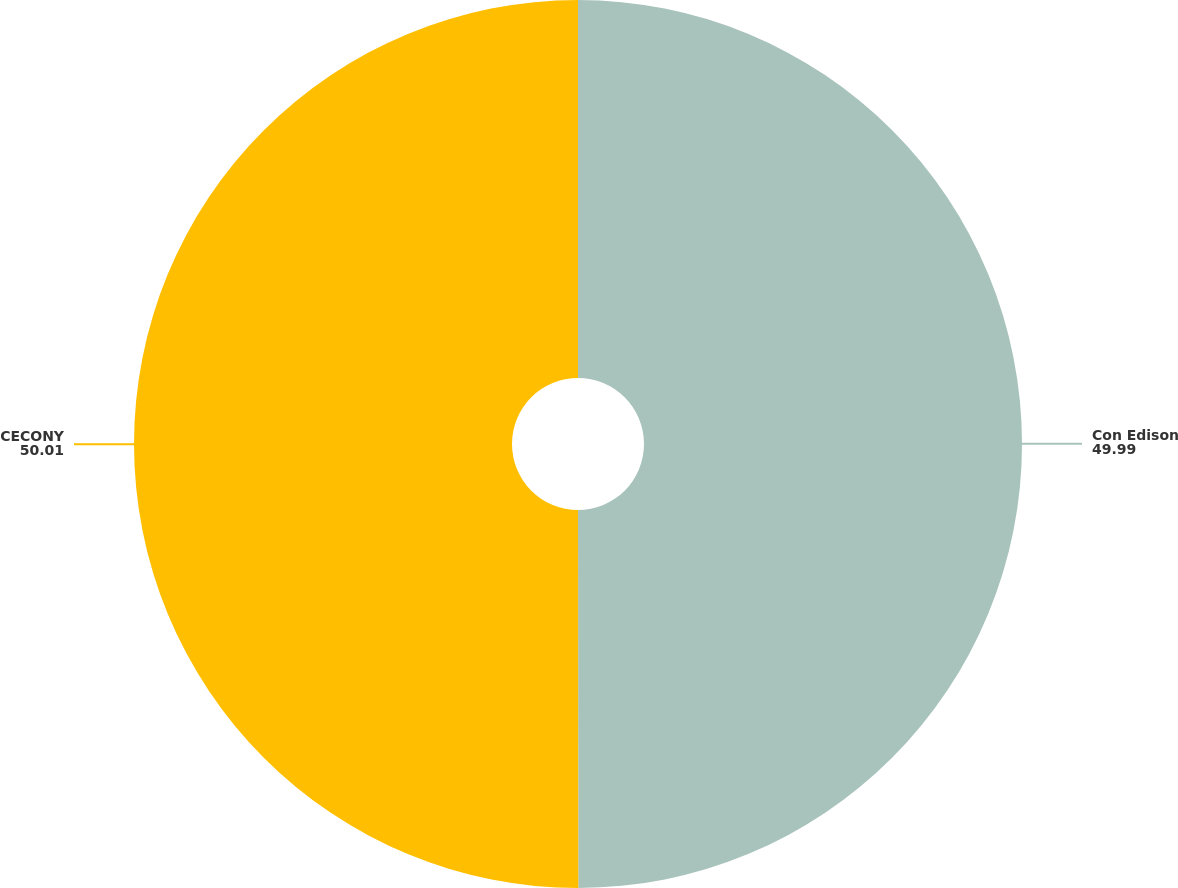<chart> <loc_0><loc_0><loc_500><loc_500><pie_chart><fcel>Con Edison<fcel>CECONY<nl><fcel>49.99%<fcel>50.01%<nl></chart> 